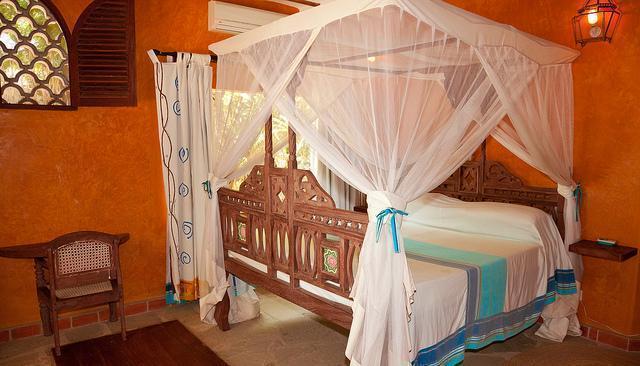The walls are most likely covered in what material?
Select the accurate response from the four choices given to answer the question.
Options: Slate, plaster, wood, canvas. Plaster. 